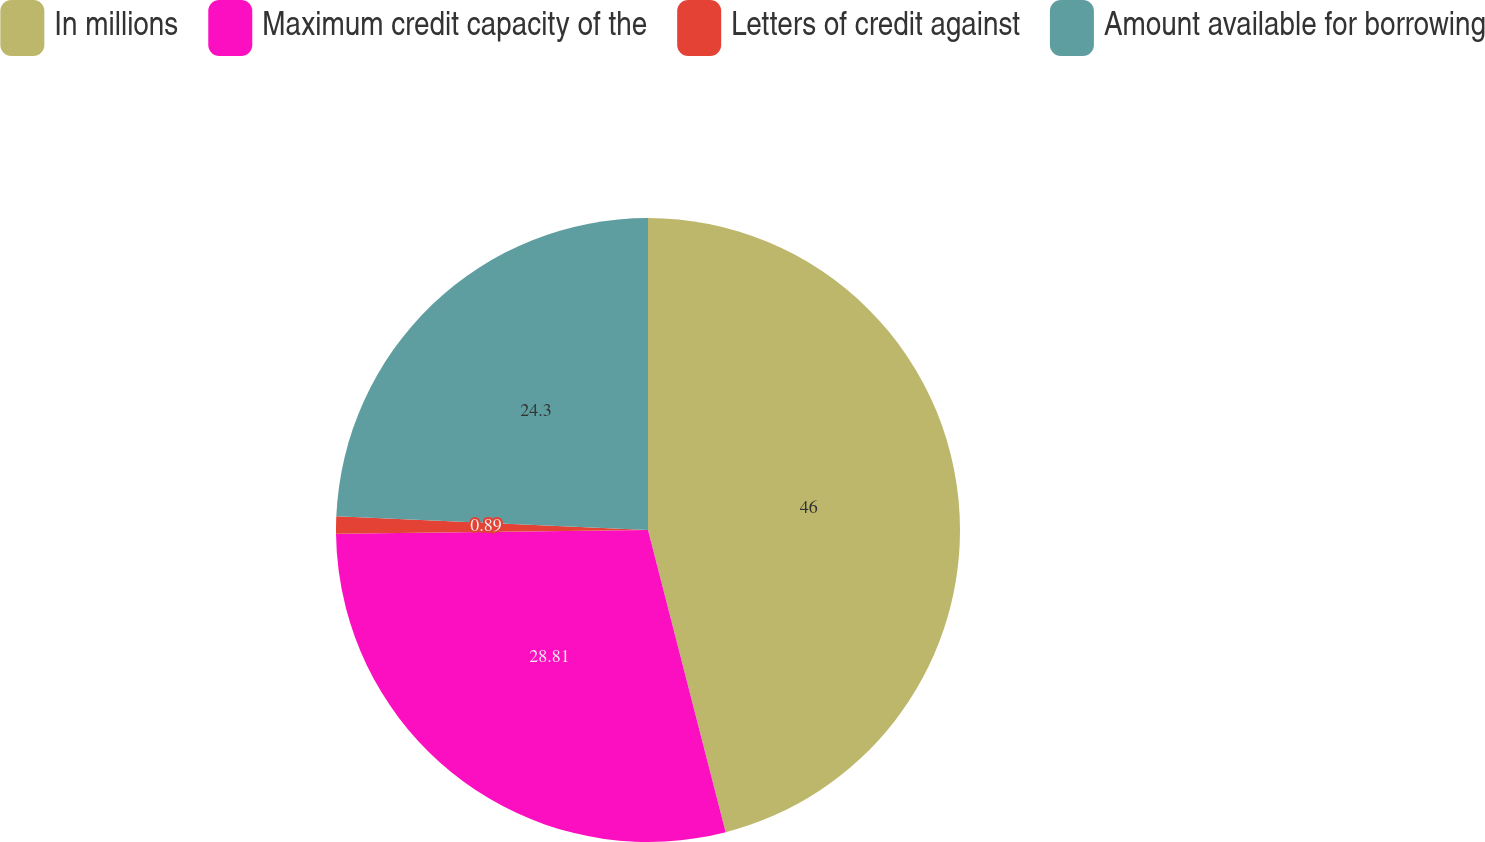Convert chart to OTSL. <chart><loc_0><loc_0><loc_500><loc_500><pie_chart><fcel>In millions<fcel>Maximum credit capacity of the<fcel>Letters of credit against<fcel>Amount available for borrowing<nl><fcel>45.99%<fcel>28.81%<fcel>0.89%<fcel>24.3%<nl></chart> 